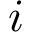Convert formula to latex. <formula><loc_0><loc_0><loc_500><loc_500>i</formula> 